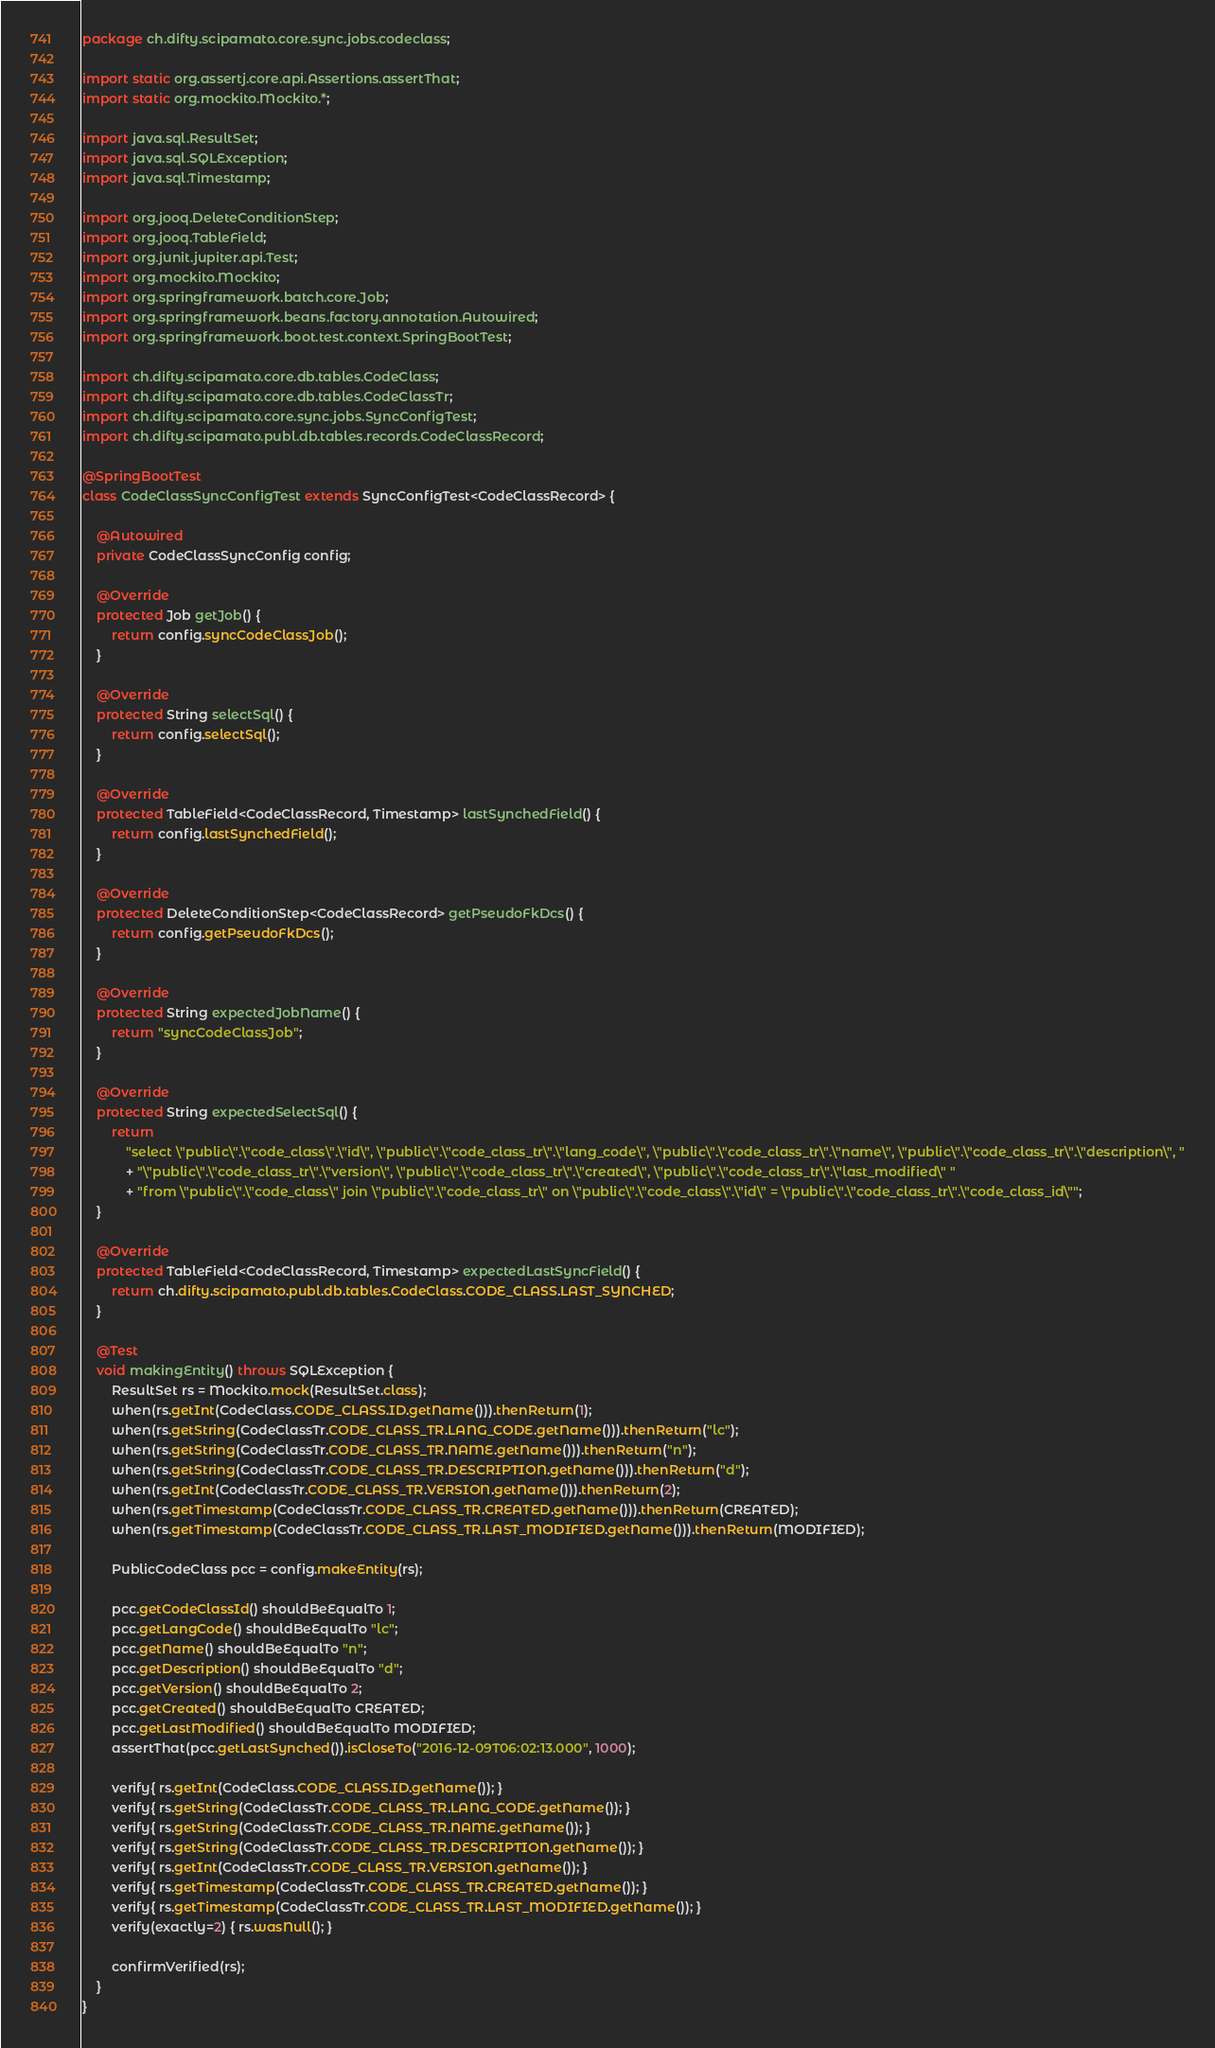<code> <loc_0><loc_0><loc_500><loc_500><_Java_>package ch.difty.scipamato.core.sync.jobs.codeclass;

import static org.assertj.core.api.Assertions.assertThat;
import static org.mockito.Mockito.*;

import java.sql.ResultSet;
import java.sql.SQLException;
import java.sql.Timestamp;

import org.jooq.DeleteConditionStep;
import org.jooq.TableField;
import org.junit.jupiter.api.Test;
import org.mockito.Mockito;
import org.springframework.batch.core.Job;
import org.springframework.beans.factory.annotation.Autowired;
import org.springframework.boot.test.context.SpringBootTest;

import ch.difty.scipamato.core.db.tables.CodeClass;
import ch.difty.scipamato.core.db.tables.CodeClassTr;
import ch.difty.scipamato.core.sync.jobs.SyncConfigTest;
import ch.difty.scipamato.publ.db.tables.records.CodeClassRecord;

@SpringBootTest
class CodeClassSyncConfigTest extends SyncConfigTest<CodeClassRecord> {

    @Autowired
    private CodeClassSyncConfig config;

    @Override
    protected Job getJob() {
        return config.syncCodeClassJob();
    }

    @Override
    protected String selectSql() {
        return config.selectSql();
    }

    @Override
    protected TableField<CodeClassRecord, Timestamp> lastSynchedField() {
        return config.lastSynchedField();
    }

    @Override
    protected DeleteConditionStep<CodeClassRecord> getPseudoFkDcs() {
        return config.getPseudoFkDcs();
    }

    @Override
    protected String expectedJobName() {
        return "syncCodeClassJob";
    }

    @Override
    protected String expectedSelectSql() {
        return
            "select \"public\".\"code_class\".\"id\", \"public\".\"code_class_tr\".\"lang_code\", \"public\".\"code_class_tr\".\"name\", \"public\".\"code_class_tr\".\"description\", "
            + "\"public\".\"code_class_tr\".\"version\", \"public\".\"code_class_tr\".\"created\", \"public\".\"code_class_tr\".\"last_modified\" "
            + "from \"public\".\"code_class\" join \"public\".\"code_class_tr\" on \"public\".\"code_class\".\"id\" = \"public\".\"code_class_tr\".\"code_class_id\"";
    }

    @Override
    protected TableField<CodeClassRecord, Timestamp> expectedLastSyncField() {
        return ch.difty.scipamato.publ.db.tables.CodeClass.CODE_CLASS.LAST_SYNCHED;
    }

    @Test
    void makingEntity() throws SQLException {
        ResultSet rs = Mockito.mock(ResultSet.class);
        when(rs.getInt(CodeClass.CODE_CLASS.ID.getName())).thenReturn(1);
        when(rs.getString(CodeClassTr.CODE_CLASS_TR.LANG_CODE.getName())).thenReturn("lc");
        when(rs.getString(CodeClassTr.CODE_CLASS_TR.NAME.getName())).thenReturn("n");
        when(rs.getString(CodeClassTr.CODE_CLASS_TR.DESCRIPTION.getName())).thenReturn("d");
        when(rs.getInt(CodeClassTr.CODE_CLASS_TR.VERSION.getName())).thenReturn(2);
        when(rs.getTimestamp(CodeClassTr.CODE_CLASS_TR.CREATED.getName())).thenReturn(CREATED);
        when(rs.getTimestamp(CodeClassTr.CODE_CLASS_TR.LAST_MODIFIED.getName())).thenReturn(MODIFIED);

        PublicCodeClass pcc = config.makeEntity(rs);

        pcc.getCodeClassId() shouldBeEqualTo 1;
        pcc.getLangCode() shouldBeEqualTo "lc";
        pcc.getName() shouldBeEqualTo "n";
        pcc.getDescription() shouldBeEqualTo "d";
        pcc.getVersion() shouldBeEqualTo 2;
        pcc.getCreated() shouldBeEqualTo CREATED;
        pcc.getLastModified() shouldBeEqualTo MODIFIED;
        assertThat(pcc.getLastSynched()).isCloseTo("2016-12-09T06:02:13.000", 1000);

        verify{ rs.getInt(CodeClass.CODE_CLASS.ID.getName()); }
        verify{ rs.getString(CodeClassTr.CODE_CLASS_TR.LANG_CODE.getName()); }
        verify{ rs.getString(CodeClassTr.CODE_CLASS_TR.NAME.getName()); }
        verify{ rs.getString(CodeClassTr.CODE_CLASS_TR.DESCRIPTION.getName()); }
        verify{ rs.getInt(CodeClassTr.CODE_CLASS_TR.VERSION.getName()); }
        verify{ rs.getTimestamp(CodeClassTr.CODE_CLASS_TR.CREATED.getName()); }
        verify{ rs.getTimestamp(CodeClassTr.CODE_CLASS_TR.LAST_MODIFIED.getName()); }
        verify(exactly=2) { rs.wasNull(); }

        confirmVerified(rs);
    }
}</code> 